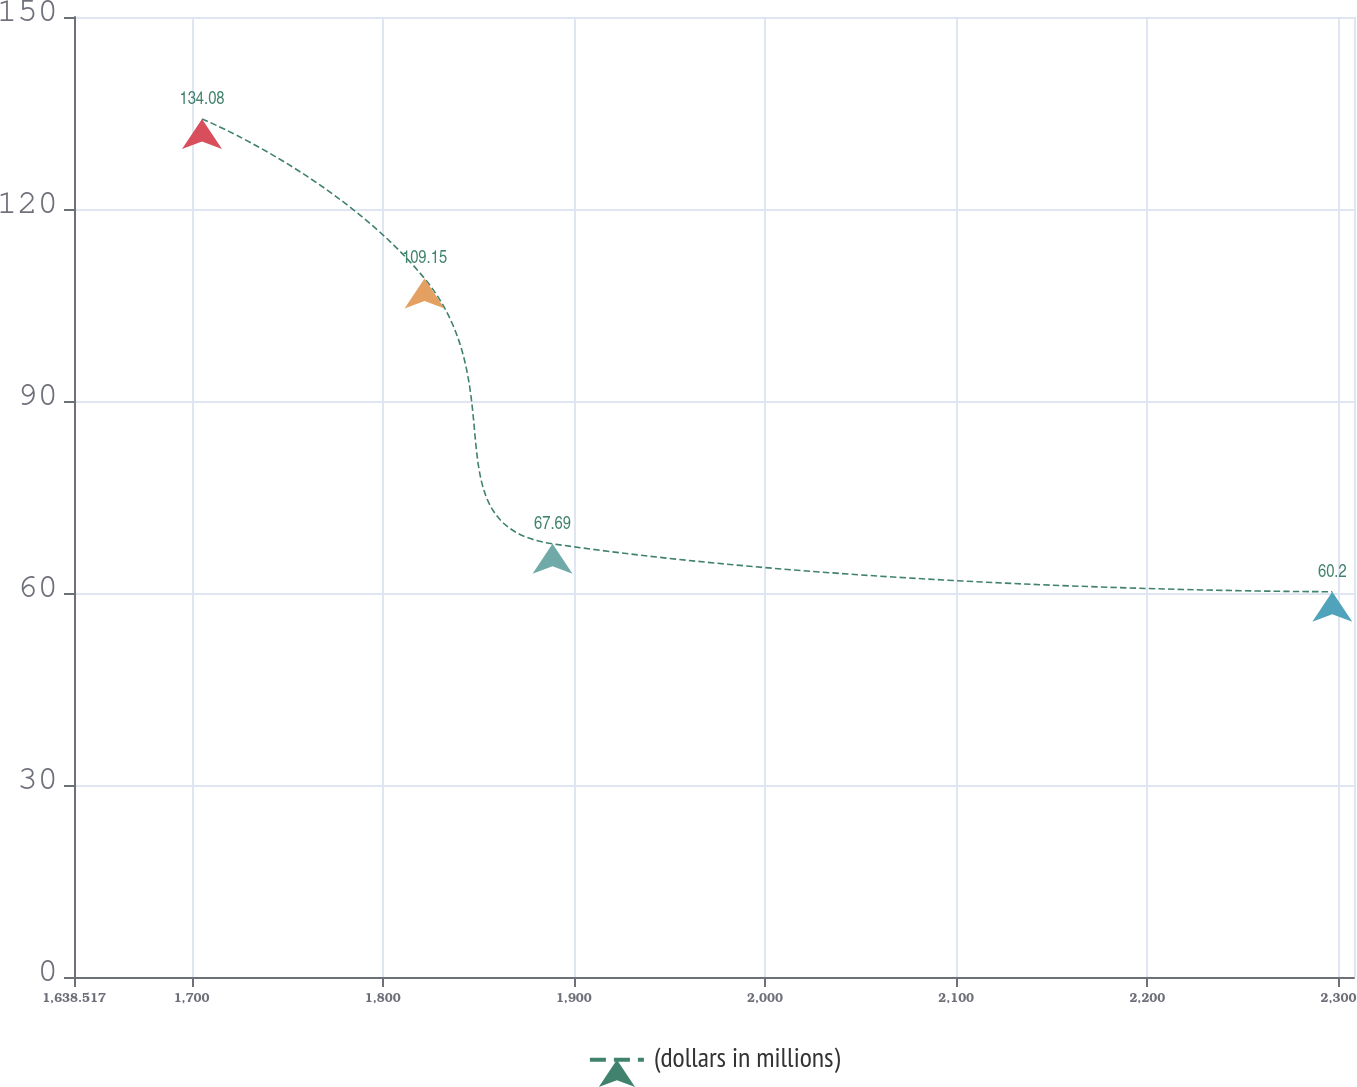<chart> <loc_0><loc_0><loc_500><loc_500><line_chart><ecel><fcel>(dollars in millions)<nl><fcel>1705.48<fcel>134.08<nl><fcel>1821.89<fcel>109.15<nl><fcel>1888.85<fcel>67.69<nl><fcel>2296.79<fcel>60.2<nl><fcel>2375.11<fcel>75.08<nl></chart> 